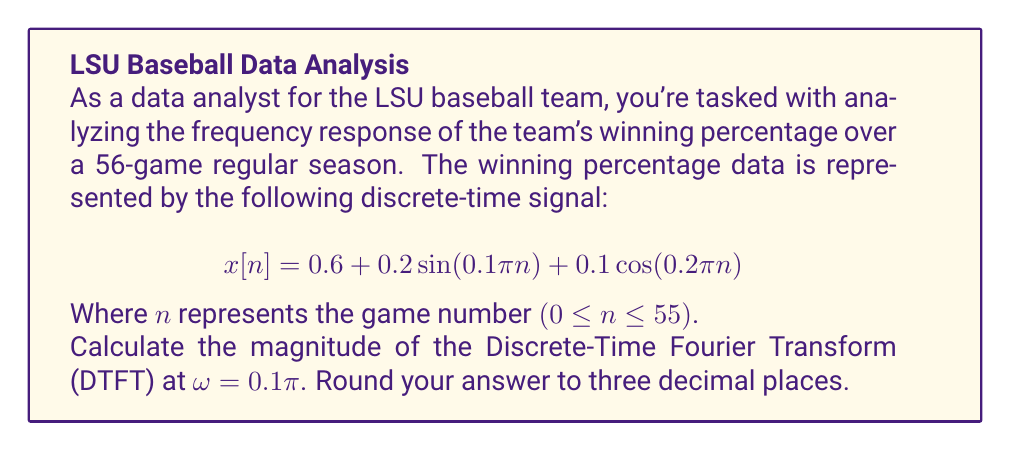What is the answer to this math problem? To solve this problem, we'll follow these steps:

1) The DTFT of a signal x[n] is given by:

   $$X(e^{j\omega}) = \sum_{n=-\infty}^{\infty} x[n]e^{-j\omega n}$$

2) For our signal:
   $$x[n] = 0.6 + 0.2 \sin(0.1\pi n) + 0.1 \cos(0.2\pi n)$$

3) We need to calculate the DTFT for each component:

   a) For the constant term 0.6:
      $$X_1(e^{j\omega}) = 0.6 \sum_{n=-\infty}^{\infty} e^{-j\omega n} = 2\pi \cdot 0.6 \cdot \delta(\omega)$$

   b) For $0.2 \sin(0.1\pi n)$:
      Using the identity $\sin(A) = \frac{e^{jA} - e^{-jA}}{2j}$,
      $$X_2(e^{j\omega}) = 0.2 \cdot \frac{1}{2j} [\pi\delta(\omega - 0.1\pi) - \pi\delta(\omega + 0.1\pi)]$$

   c) For $0.1 \cos(0.2\pi n)$:
      Using the identity $\cos(A) = \frac{e^{jA} + e^{-jA}}{2}$,
      $$X_3(e^{j\omega}) = 0.1 \cdot \frac{1}{2} [\pi\delta(\omega - 0.2\pi) + \pi\delta(\omega + 0.2\pi)]$$

4) The total DTFT is the sum of these components:
   $$X(e^{j\omega}) = X_1(e^{j\omega}) + X_2(e^{j\omega}) + X_3(e^{j\omega})$$

5) At ω = 0.1π, only $X_2(e^{j\omega})$ contributes to the magnitude:
   $$|X(e^{j0.1\pi})| = |0.2 \cdot \frac{1}{2j} \cdot \pi| = 0.1\pi$$

6) Converting to decimal and rounding to three places:
   $$0.1\pi \approx 0.314$$

Therefore, the magnitude of the DTFT at ω = 0.1π is approximately 0.314.
Answer: 0.314 